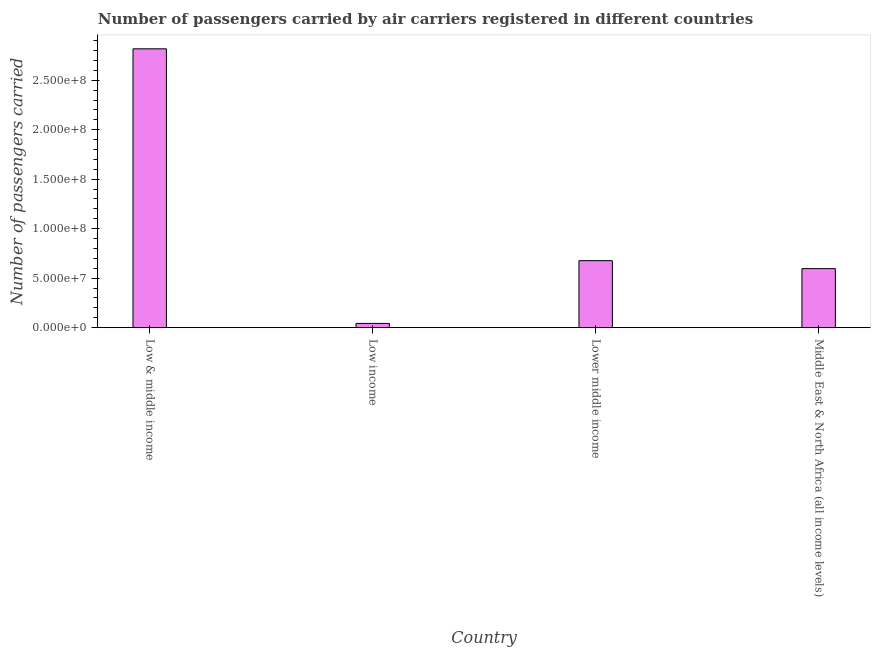Does the graph contain any zero values?
Keep it short and to the point. No. Does the graph contain grids?
Provide a succinct answer. No. What is the title of the graph?
Keep it short and to the point. Number of passengers carried by air carriers registered in different countries. What is the label or title of the Y-axis?
Keep it short and to the point. Number of passengers carried. What is the number of passengers carried in Low income?
Ensure brevity in your answer.  4.29e+06. Across all countries, what is the maximum number of passengers carried?
Give a very brief answer. 2.82e+08. Across all countries, what is the minimum number of passengers carried?
Give a very brief answer. 4.29e+06. In which country was the number of passengers carried minimum?
Give a very brief answer. Low income. What is the sum of the number of passengers carried?
Provide a succinct answer. 4.13e+08. What is the difference between the number of passengers carried in Low & middle income and Lower middle income?
Offer a very short reply. 2.14e+08. What is the average number of passengers carried per country?
Offer a terse response. 1.03e+08. What is the median number of passengers carried?
Provide a succinct answer. 6.37e+07. In how many countries, is the number of passengers carried greater than 40000000 ?
Your answer should be very brief. 3. What is the ratio of the number of passengers carried in Low & middle income to that in Lower middle income?
Your response must be concise. 4.16. Is the difference between the number of passengers carried in Lower middle income and Middle East & North Africa (all income levels) greater than the difference between any two countries?
Provide a short and direct response. No. What is the difference between the highest and the second highest number of passengers carried?
Provide a short and direct response. 2.14e+08. What is the difference between the highest and the lowest number of passengers carried?
Offer a very short reply. 2.77e+08. What is the Number of passengers carried in Low & middle income?
Provide a short and direct response. 2.82e+08. What is the Number of passengers carried in Low income?
Give a very brief answer. 4.29e+06. What is the Number of passengers carried in Lower middle income?
Give a very brief answer. 6.77e+07. What is the Number of passengers carried in Middle East & North Africa (all income levels)?
Your answer should be compact. 5.97e+07. What is the difference between the Number of passengers carried in Low & middle income and Low income?
Give a very brief answer. 2.77e+08. What is the difference between the Number of passengers carried in Low & middle income and Lower middle income?
Make the answer very short. 2.14e+08. What is the difference between the Number of passengers carried in Low & middle income and Middle East & North Africa (all income levels)?
Provide a short and direct response. 2.22e+08. What is the difference between the Number of passengers carried in Low income and Lower middle income?
Your answer should be compact. -6.34e+07. What is the difference between the Number of passengers carried in Low income and Middle East & North Africa (all income levels)?
Offer a very short reply. -5.54e+07. What is the difference between the Number of passengers carried in Lower middle income and Middle East & North Africa (all income levels)?
Your answer should be very brief. 8.03e+06. What is the ratio of the Number of passengers carried in Low & middle income to that in Low income?
Give a very brief answer. 65.64. What is the ratio of the Number of passengers carried in Low & middle income to that in Lower middle income?
Provide a succinct answer. 4.16. What is the ratio of the Number of passengers carried in Low & middle income to that in Middle East & North Africa (all income levels)?
Keep it short and to the point. 4.72. What is the ratio of the Number of passengers carried in Low income to that in Lower middle income?
Provide a succinct answer. 0.06. What is the ratio of the Number of passengers carried in Low income to that in Middle East & North Africa (all income levels)?
Offer a terse response. 0.07. What is the ratio of the Number of passengers carried in Lower middle income to that in Middle East & North Africa (all income levels)?
Give a very brief answer. 1.14. 